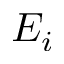Convert formula to latex. <formula><loc_0><loc_0><loc_500><loc_500>E _ { i }</formula> 